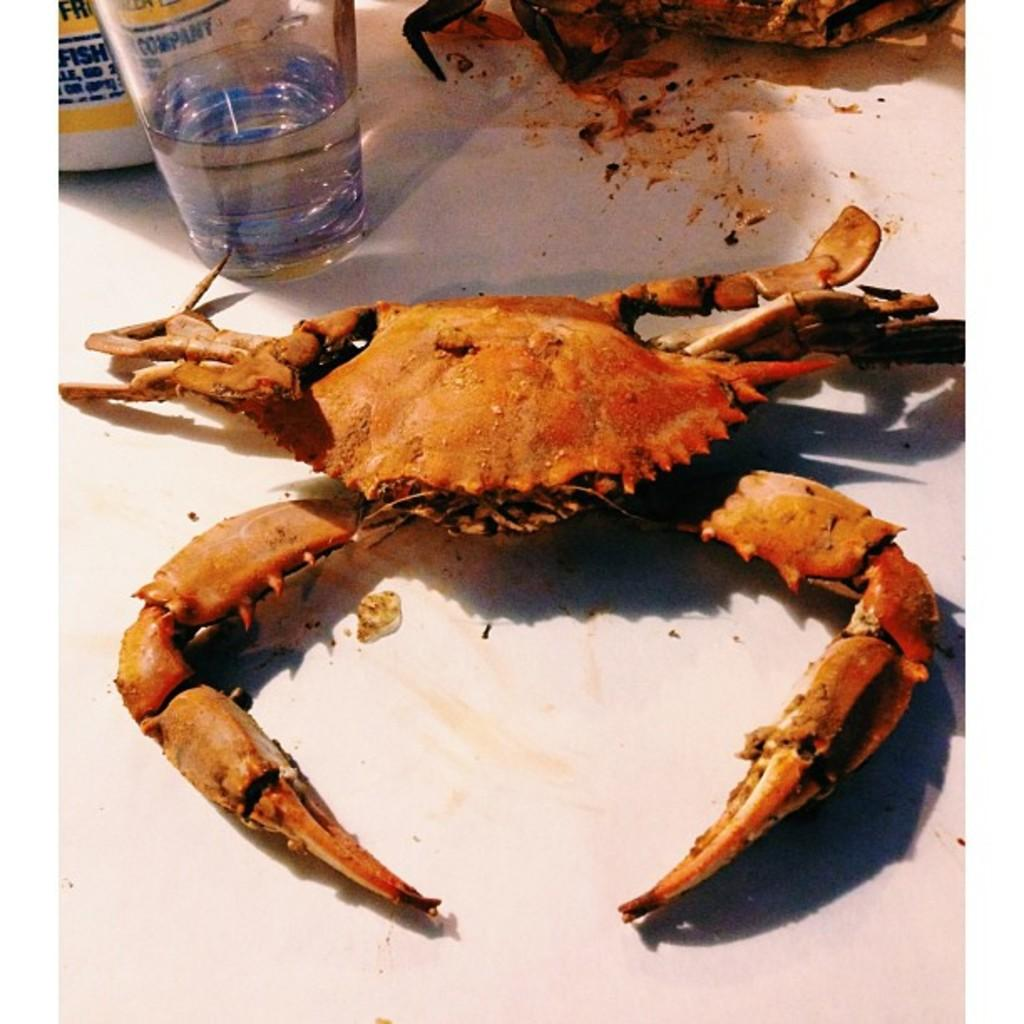What type of animal is in the image? There is a crab in the image. What is contained in the glass that is visible in the image? There is water in the glass in the image. What color is the surface in the image? The surface in the image is white. How many eyes does the transport have in the image? There is no transport present in the image, so it is not possible to determine the number of eyes it might have. 